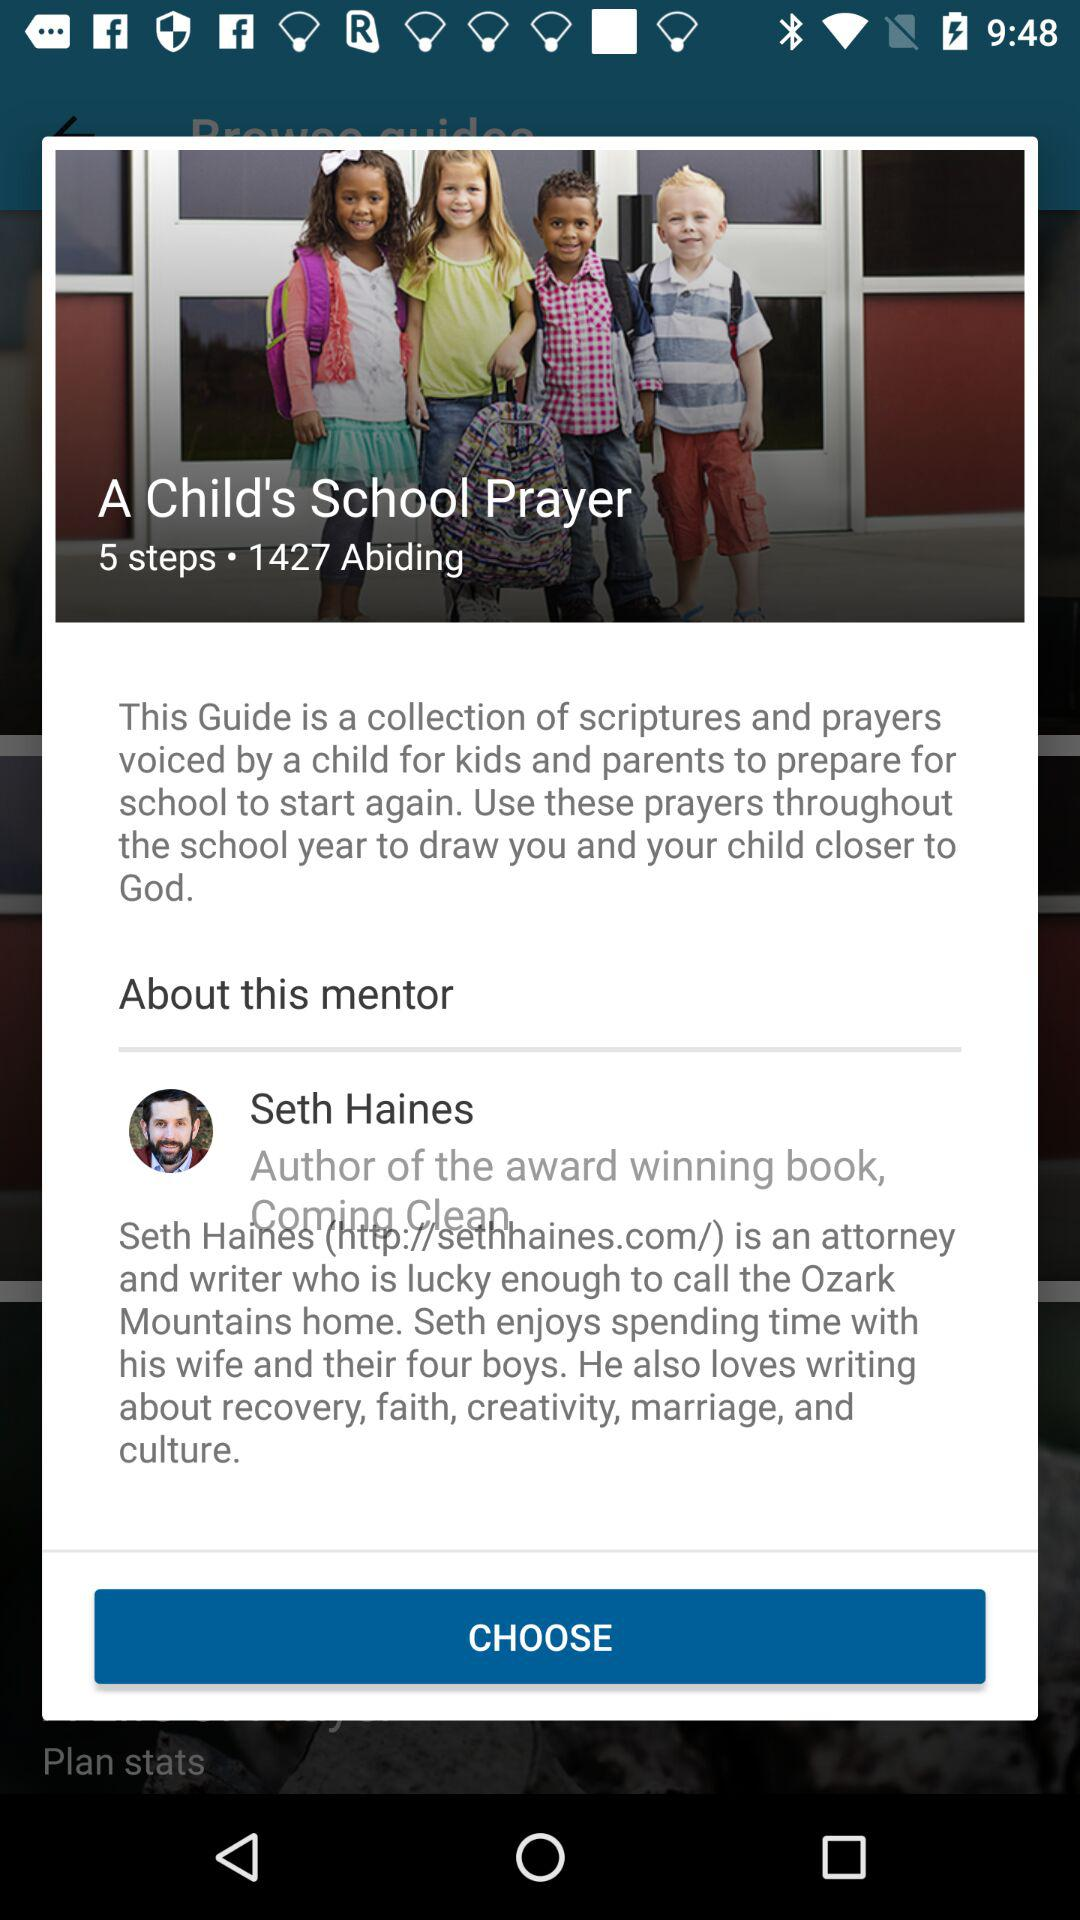How many steps are there? There are 5 steps. 